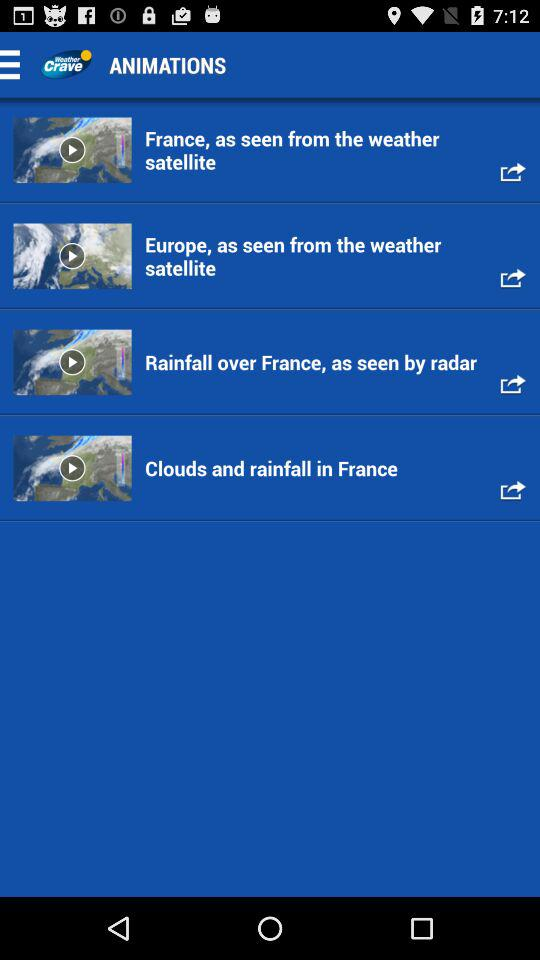What is the application name? The application name is "Weather Crave". 